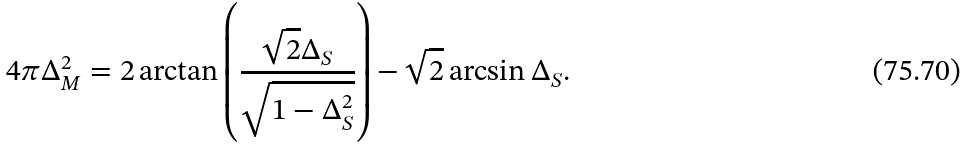Convert formula to latex. <formula><loc_0><loc_0><loc_500><loc_500>4 \pi \Delta _ { M } ^ { 2 } = 2 \arctan \left ( \frac { \sqrt { 2 } \Delta _ { S } } { \sqrt { 1 - \Delta _ { S } ^ { 2 } } } \right ) - \sqrt { 2 } \arcsin { \Delta _ { S } } .</formula> 